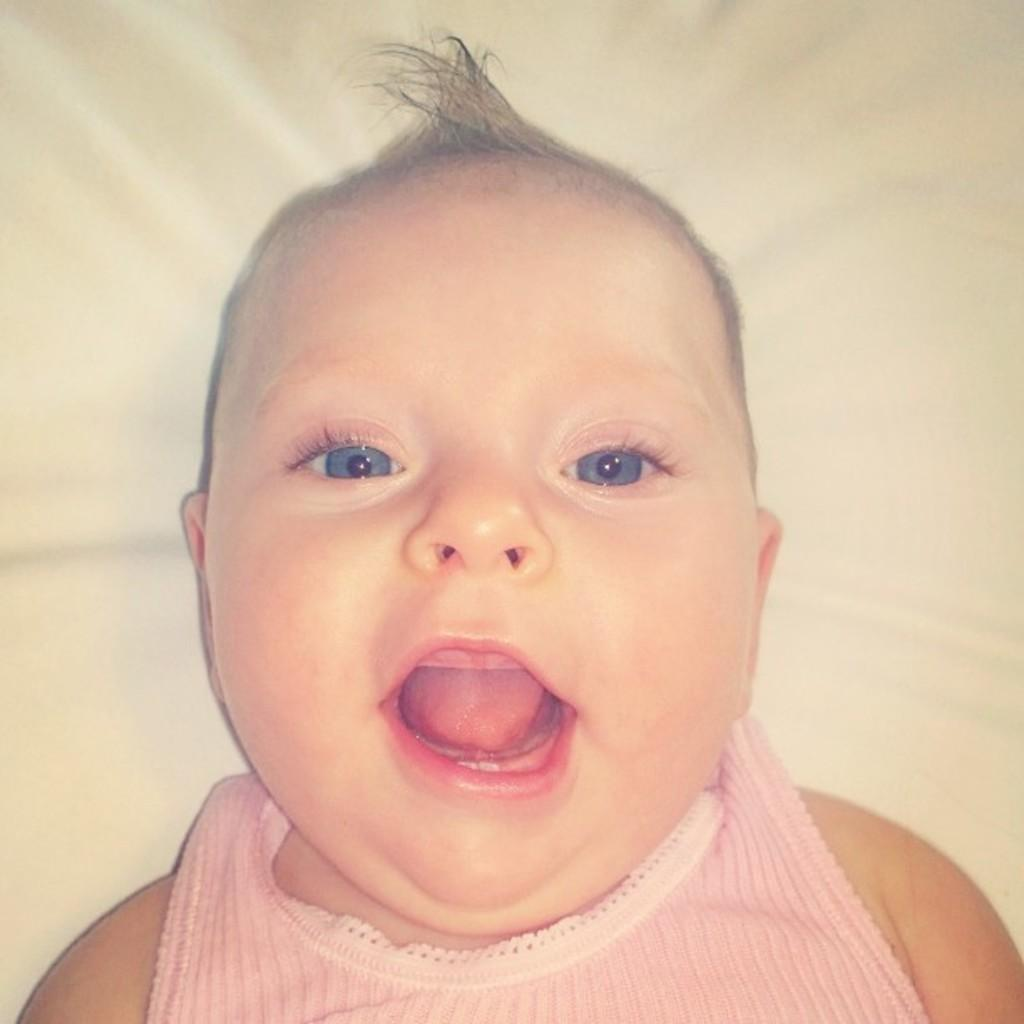What is the main subject of the image? The main subject of the image is a baby. What is the baby lying on? The baby is lying on a cloth. What type of honey is being poured on the baby's skin in the image? There is no honey or pouring action present in the image; the baby is simply lying on a cloth. 